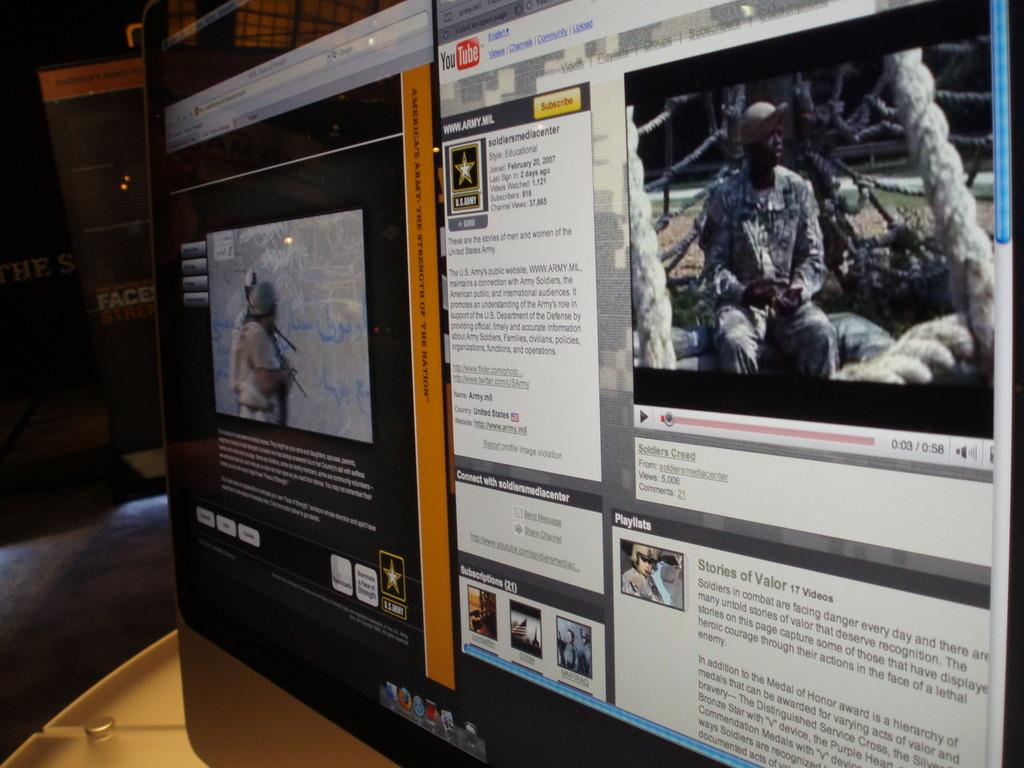<image>
Provide a brief description of the given image. A computer screen shows a You Tube page featuring soldiers. 